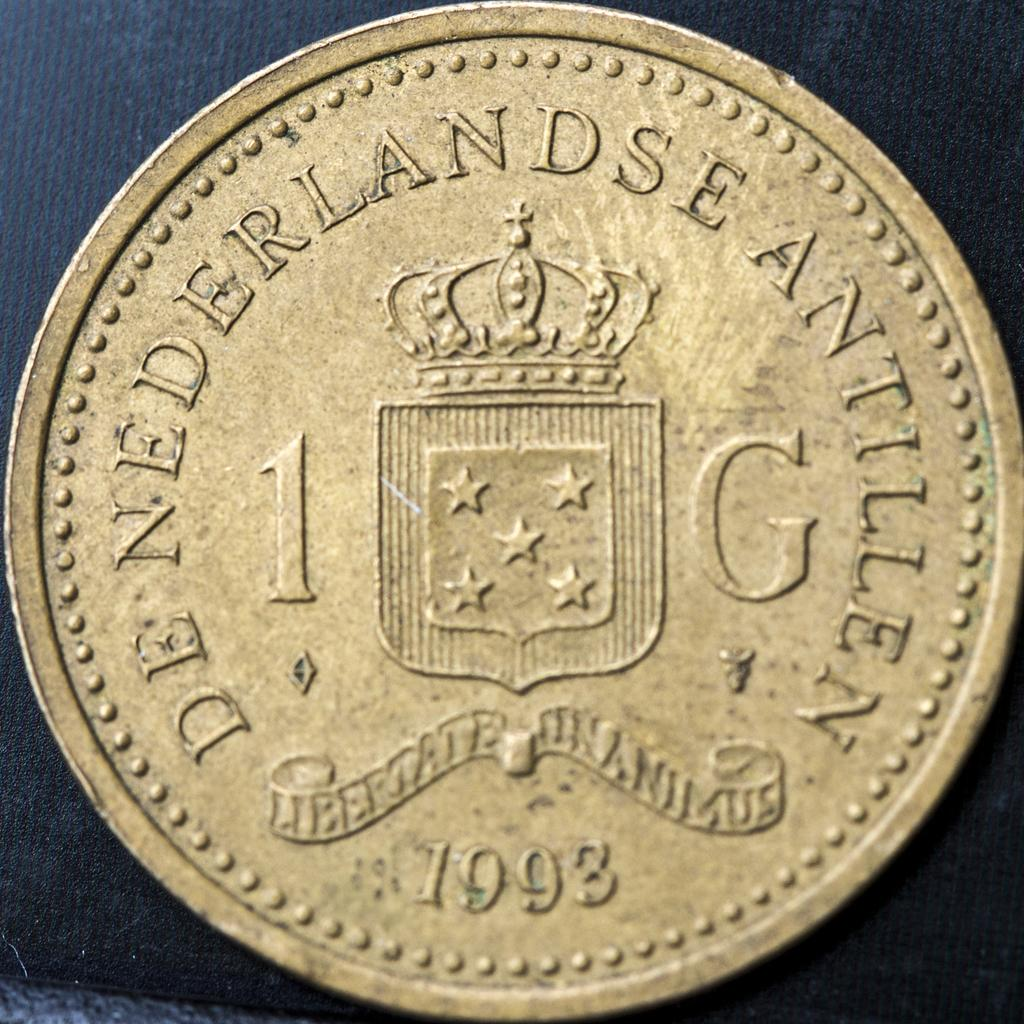Provide a one-sentence caption for the provided image. A gold colored coin stamped with the date 1993. 